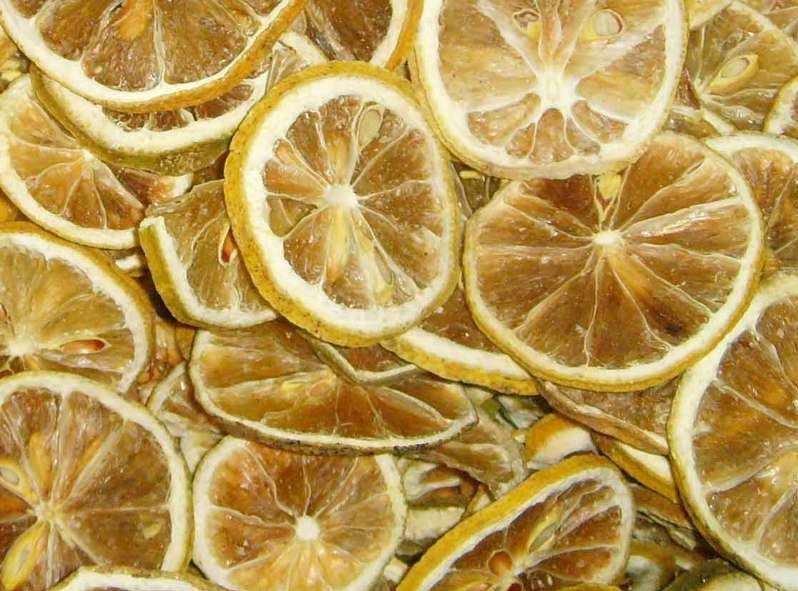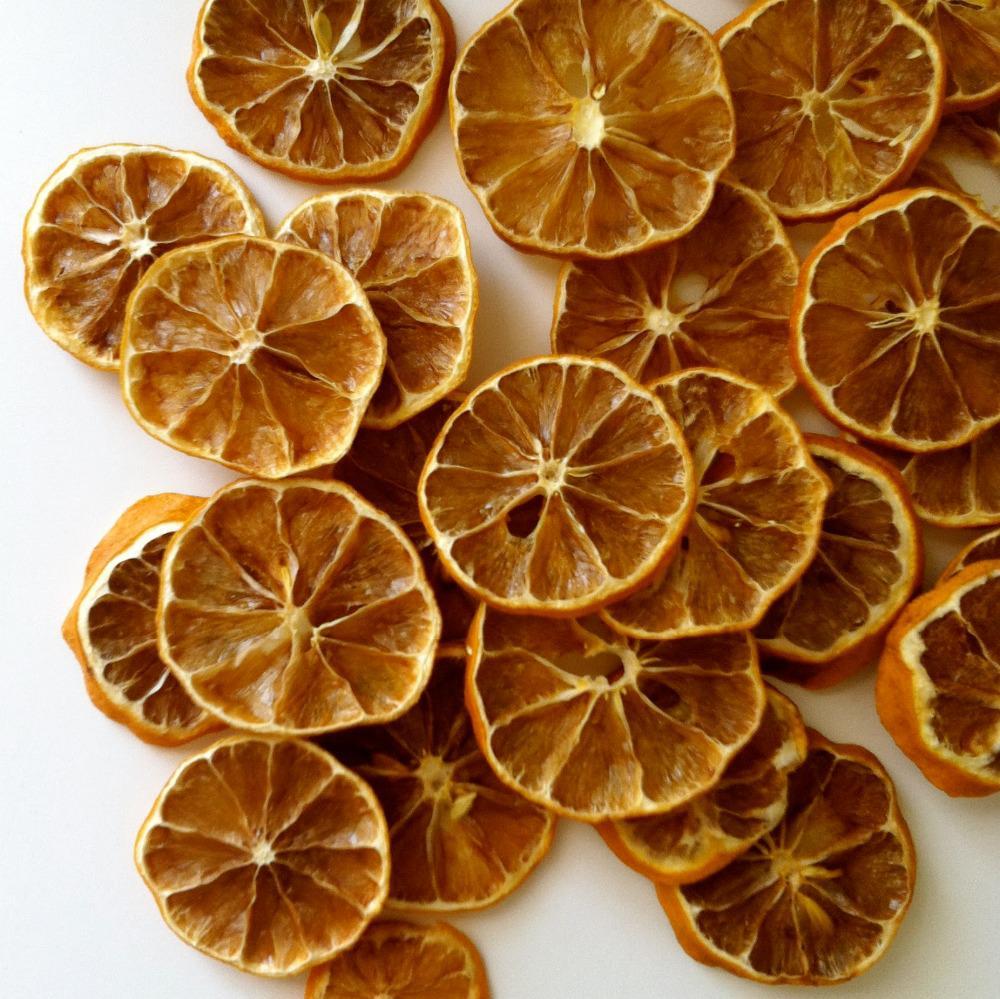The first image is the image on the left, the second image is the image on the right. For the images displayed, is the sentence "There are dried sliced oranges in a back bowl on a wooden table, there is a tea cup next to the bowl" factually correct? Answer yes or no. No. The first image is the image on the left, the second image is the image on the right. Considering the images on both sides, is "Some of the lemons are not sliced." valid? Answer yes or no. No. 